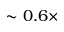Convert formula to latex. <formula><loc_0><loc_0><loc_500><loc_500>\sim 0 . 6 \times</formula> 